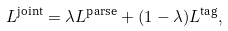<formula> <loc_0><loc_0><loc_500><loc_500>L ^ { \text {joint} } = \lambda L ^ { \text {parse} } + ( 1 - \lambda ) L ^ { \text {tag} } ,</formula> 